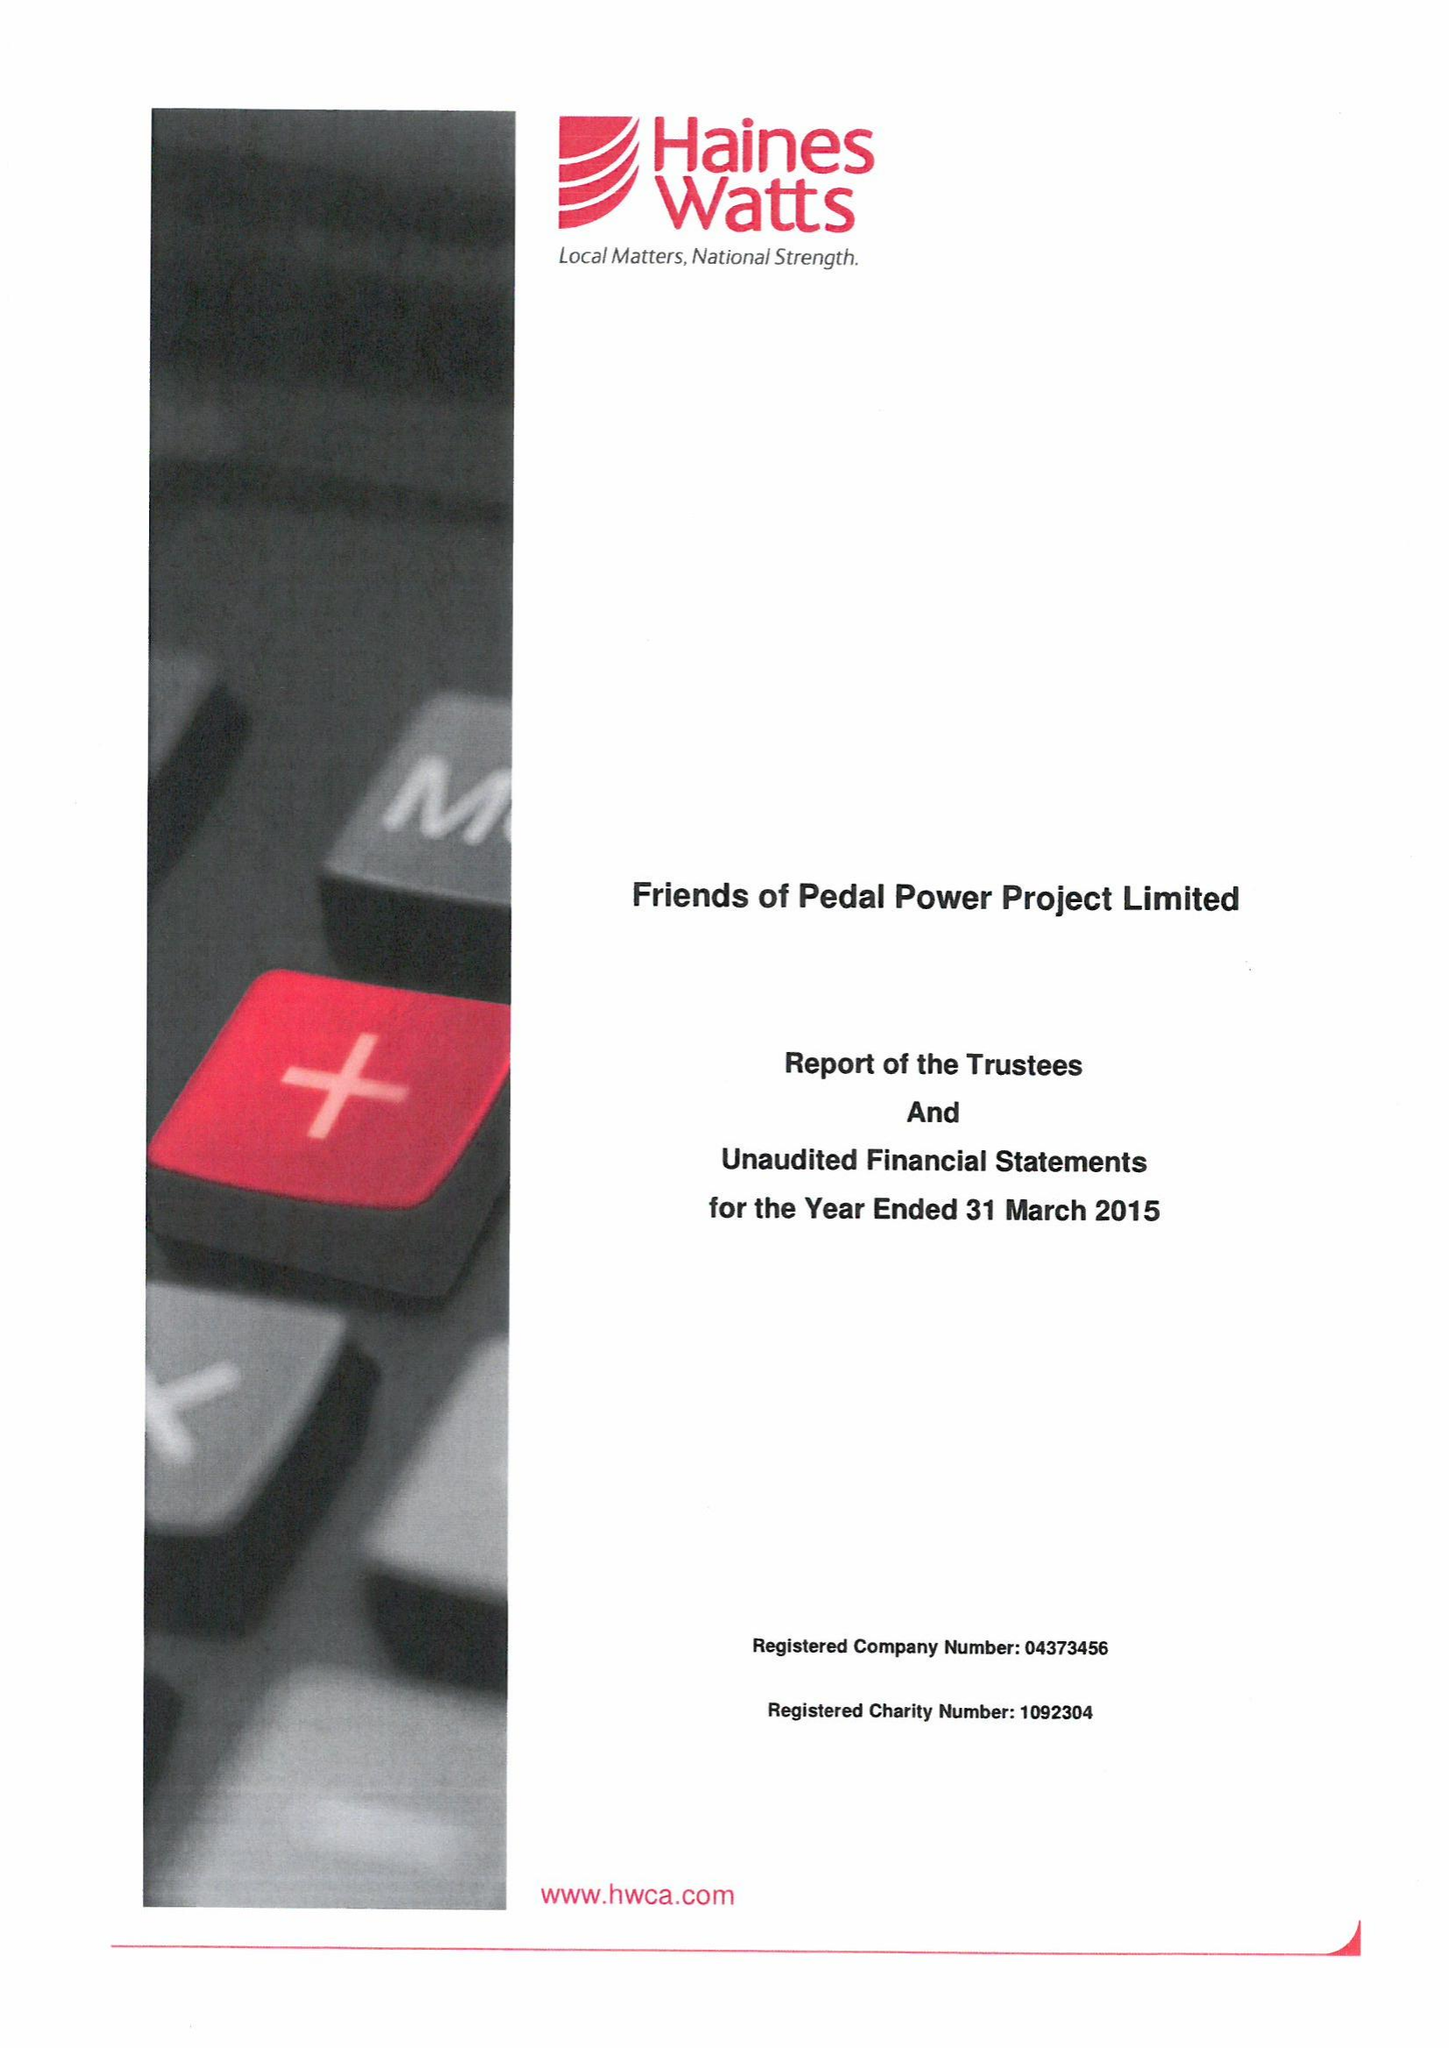What is the value for the address__postcode?
Answer the question using a single word or phrase. CF24 1PL 